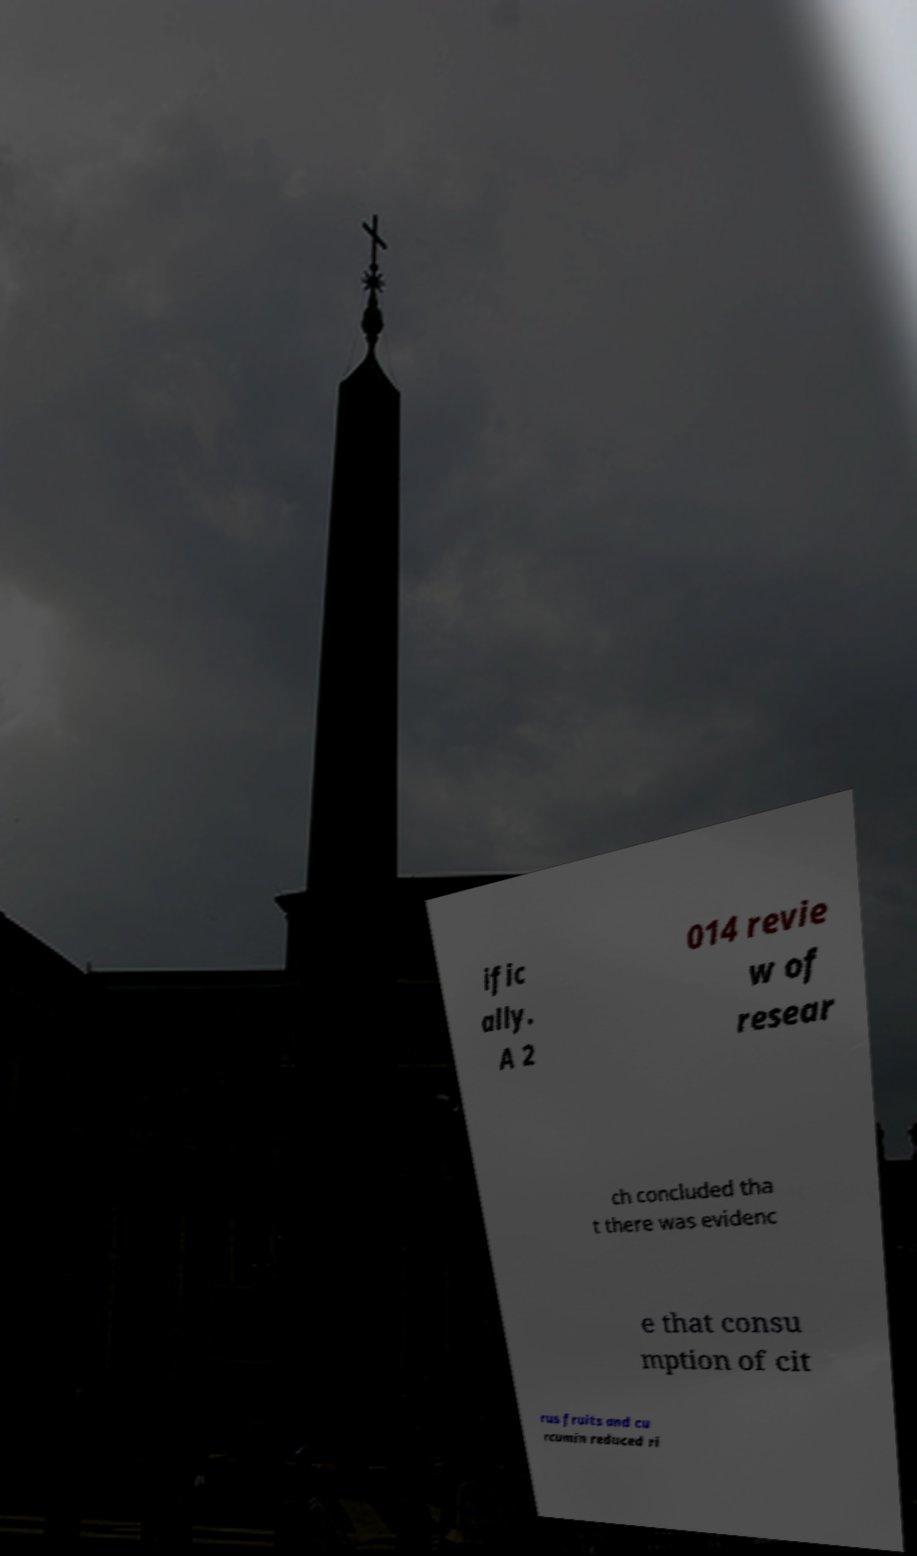Could you extract and type out the text from this image? ific ally. A 2 014 revie w of resear ch concluded tha t there was evidenc e that consu mption of cit rus fruits and cu rcumin reduced ri 